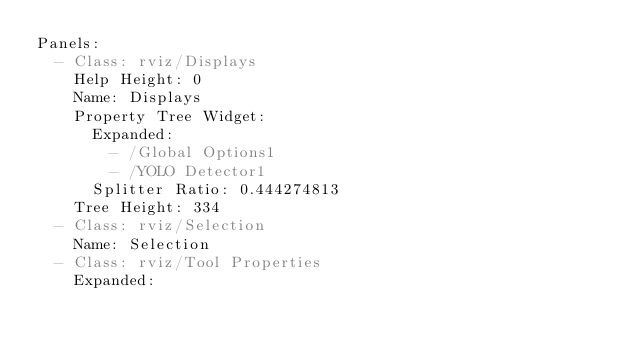Convert code to text. <code><loc_0><loc_0><loc_500><loc_500><_YAML_>Panels:
  - Class: rviz/Displays
    Help Height: 0
    Name: Displays
    Property Tree Widget:
      Expanded:
        - /Global Options1
        - /YOLO Detector1
      Splitter Ratio: 0.444274813
    Tree Height: 334
  - Class: rviz/Selection
    Name: Selection
  - Class: rviz/Tool Properties
    Expanded:</code> 